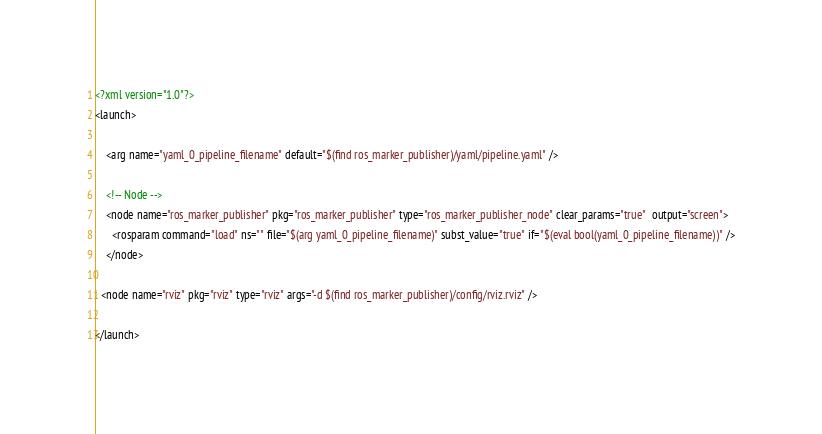<code> <loc_0><loc_0><loc_500><loc_500><_XML_><?xml version="1.0"?>
<launch>

    <arg name="yaml_0_pipeline_filename" default="$(find ros_marker_publisher)/yaml/pipeline.yaml" />

    <!-- Node -->
    <node name="ros_marker_publisher" pkg="ros_marker_publisher" type="ros_marker_publisher_node" clear_params="true"  output="screen">
      <rosparam command="load" ns="" file="$(arg yaml_0_pipeline_filename)" subst_value="true" if="$(eval bool(yaml_0_pipeline_filename))" />
    </node>

  <node name="rviz" pkg="rviz" type="rviz" args="-d $(find ros_marker_publisher)/config/rviz.rviz" />

</launch>
</code> 